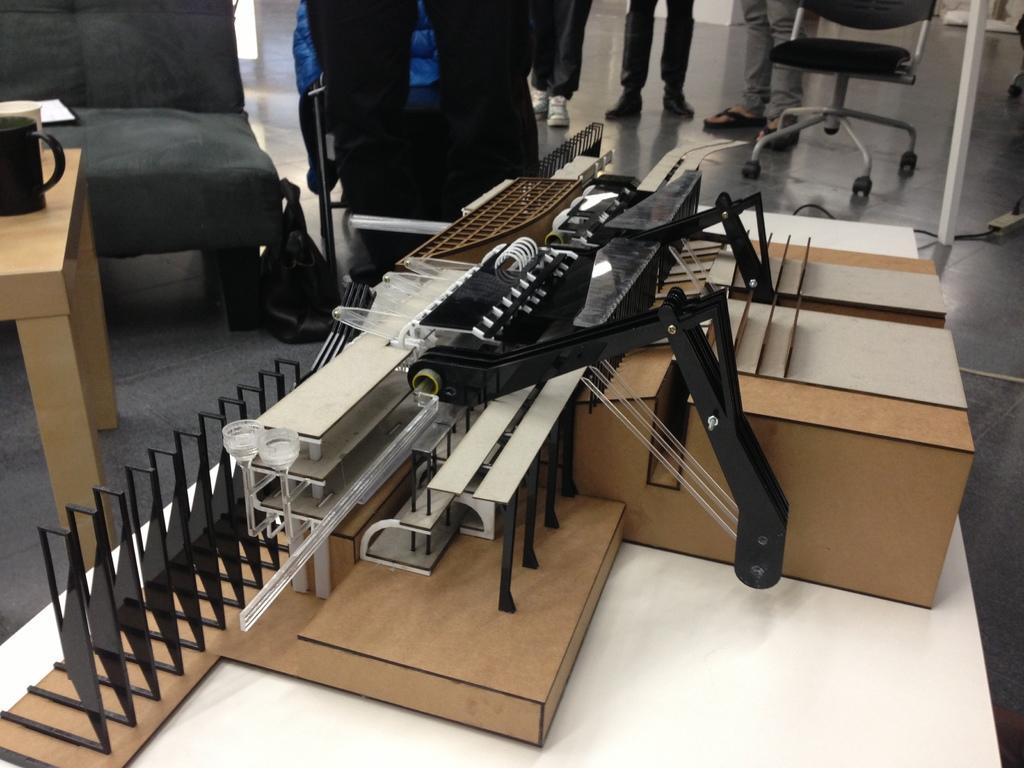Describe this image in one or two sentences. The picture consists of an object might be a catalog placed on a table. On the left there are table, couch, cups and chair. In the center of the background there are group of people, chair, cable and table. 